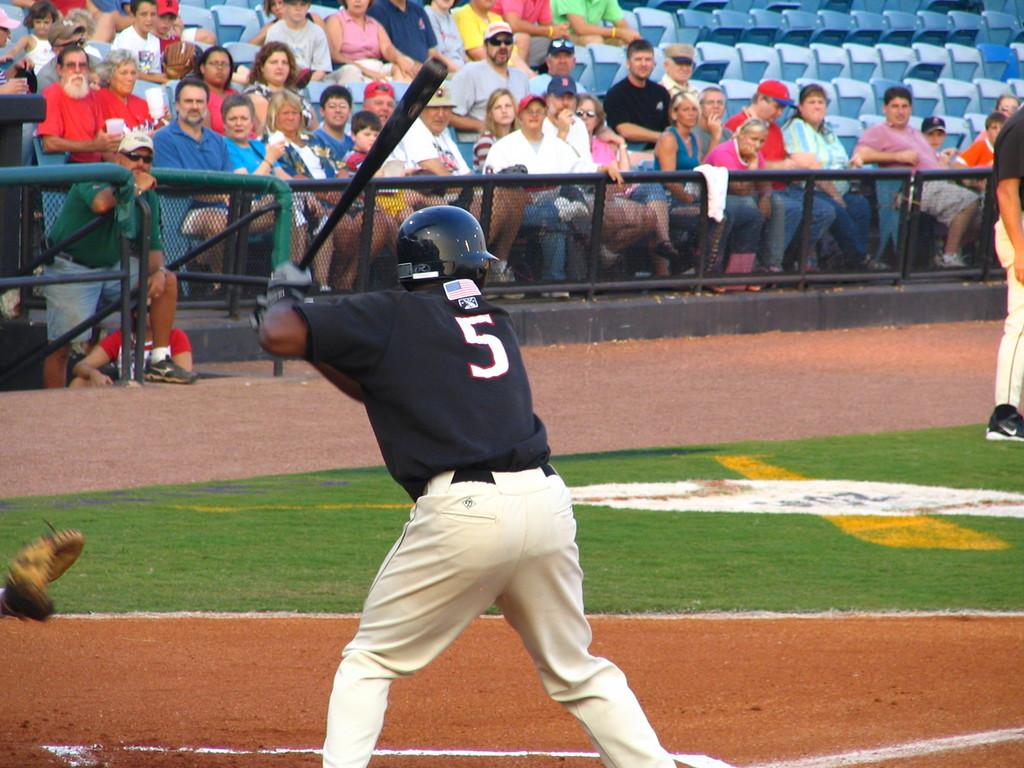What are the persons in the image doing? The persons in the image are standing on the ground. What is one of the persons holding in their hands? One of the persons is holding a bat in their hands. What can be seen in the background of the image? There are iron grills and spectators sitting on seats in the background of the image. Can you see a monkey jumping in the image? There is no monkey or jumping activity present in the image. Is the person holding the bat the grandmother of the other persons in the image? The provided facts do not mention any familial relationships between the persons in the image, so we cannot determine if the person holding the bat is the grandmother. 